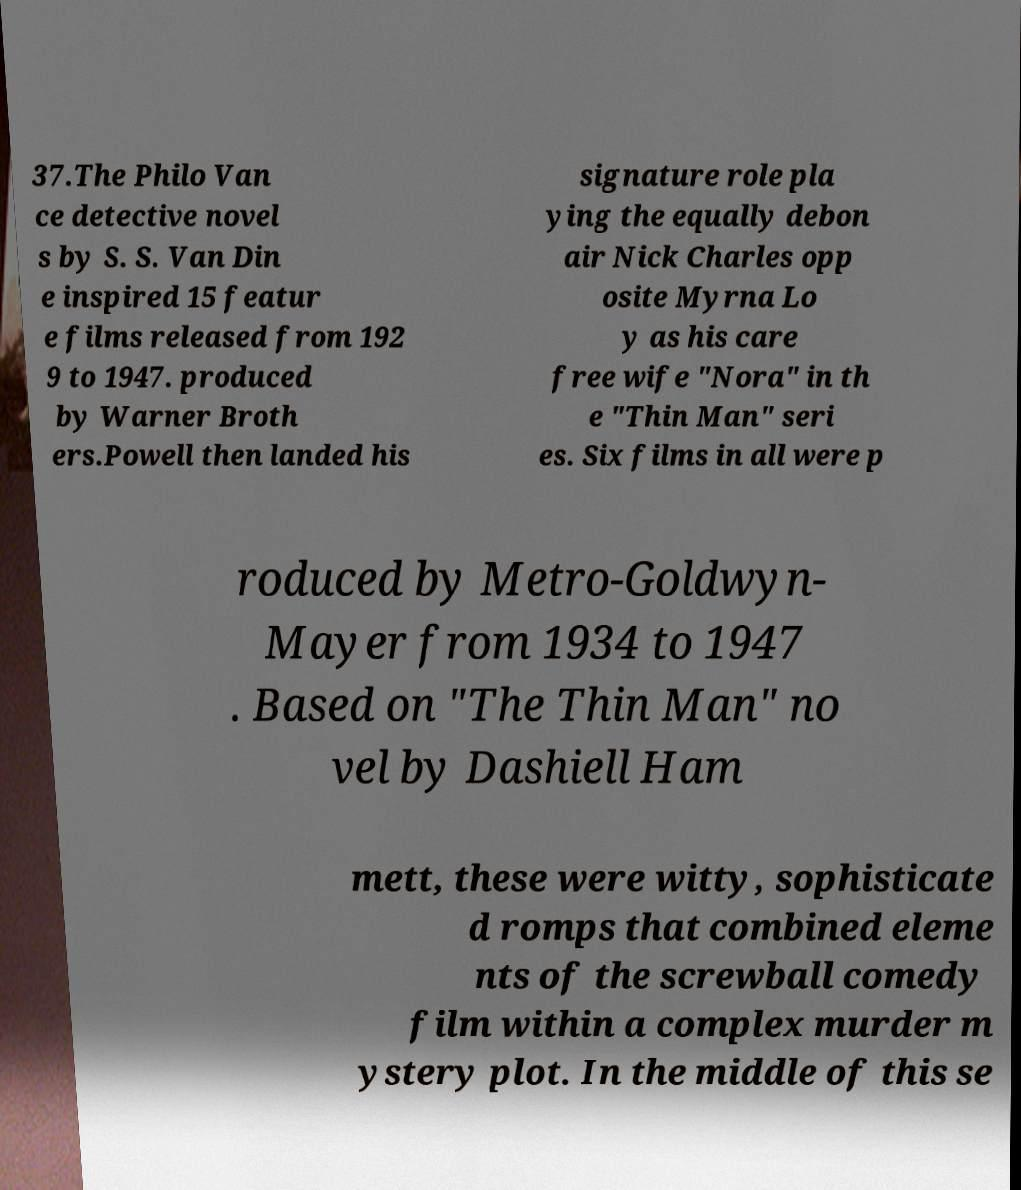Can you read and provide the text displayed in the image?This photo seems to have some interesting text. Can you extract and type it out for me? 37.The Philo Van ce detective novel s by S. S. Van Din e inspired 15 featur e films released from 192 9 to 1947. produced by Warner Broth ers.Powell then landed his signature role pla ying the equally debon air Nick Charles opp osite Myrna Lo y as his care free wife "Nora" in th e "Thin Man" seri es. Six films in all were p roduced by Metro-Goldwyn- Mayer from 1934 to 1947 . Based on "The Thin Man" no vel by Dashiell Ham mett, these were witty, sophisticate d romps that combined eleme nts of the screwball comedy film within a complex murder m ystery plot. In the middle of this se 